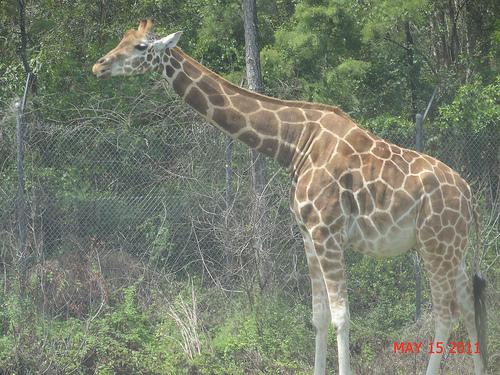Tell me about the text that appears in the image. The red text says "May 15 2011" and is printed on a white background. What is the giraffe doing and where is it located in the photo? The giraffe is standing outside near a metal fence and green trees, with ears perked up. Give a short and vivid description of the primary animal in the image. A majestic, spotted giraffe stands tall in daylight, showcasing its long and graceful neck, attentive ears, and expressive eyes. What type of fence can you see in the image? There is a tall metal fence with fence posts on the right side of the giraffe. Provide a concise summary of the image's content. The image shows a tall giraffe with unique fur patterns standing outside near a metal fence, with green trees in the background. Describe the physical appearance of the giraffe in the photo. The giraffe has a long neck, big black eyes, long ears, a short brown mane, and fur with stone-like patterned designs. Briefly describe the tree trunk and the area around it in the image. A long, thin tree trunk stands near the giraffe, surrounded by brown dead brush near the fence. Write a brief description of the primary object in the image. A giraffe with a long neck, big eyes, and brown spots is standing in daylight near a metal fence. Mention the greenery present in the image. There are green trees behind the metal fence, small green plants on the ground, and a dense area of trees and brush. List the elements you notice in the background of the image. Background features include a metal fence, green trees, a fence post, and the printed date in red text. 